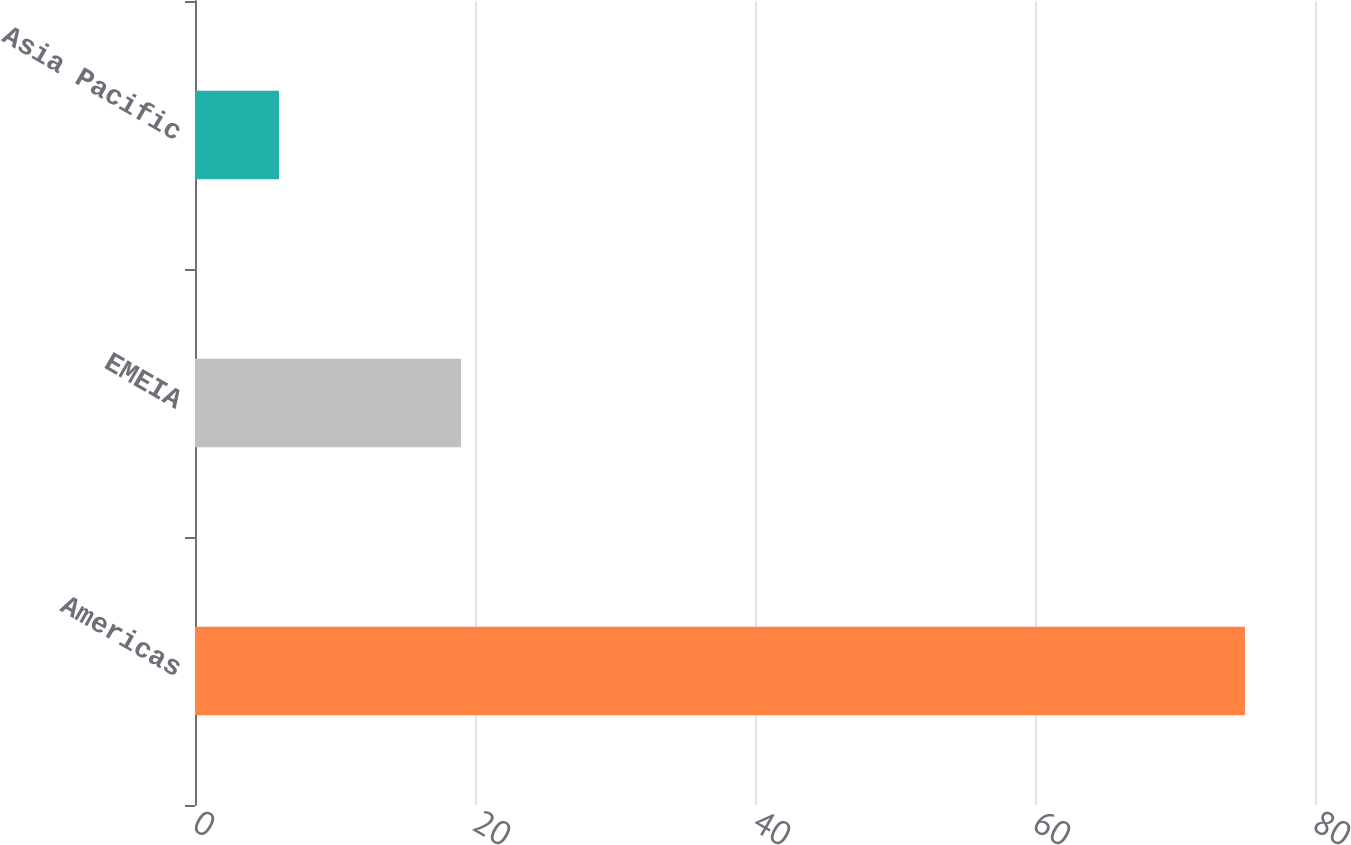Convert chart to OTSL. <chart><loc_0><loc_0><loc_500><loc_500><bar_chart><fcel>Americas<fcel>EMEIA<fcel>Asia Pacific<nl><fcel>75<fcel>19<fcel>6<nl></chart> 